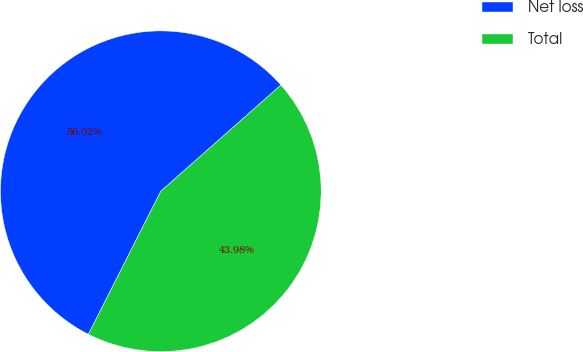Convert chart to OTSL. <chart><loc_0><loc_0><loc_500><loc_500><pie_chart><fcel>Net loss<fcel>Total<nl><fcel>56.02%<fcel>43.98%<nl></chart> 